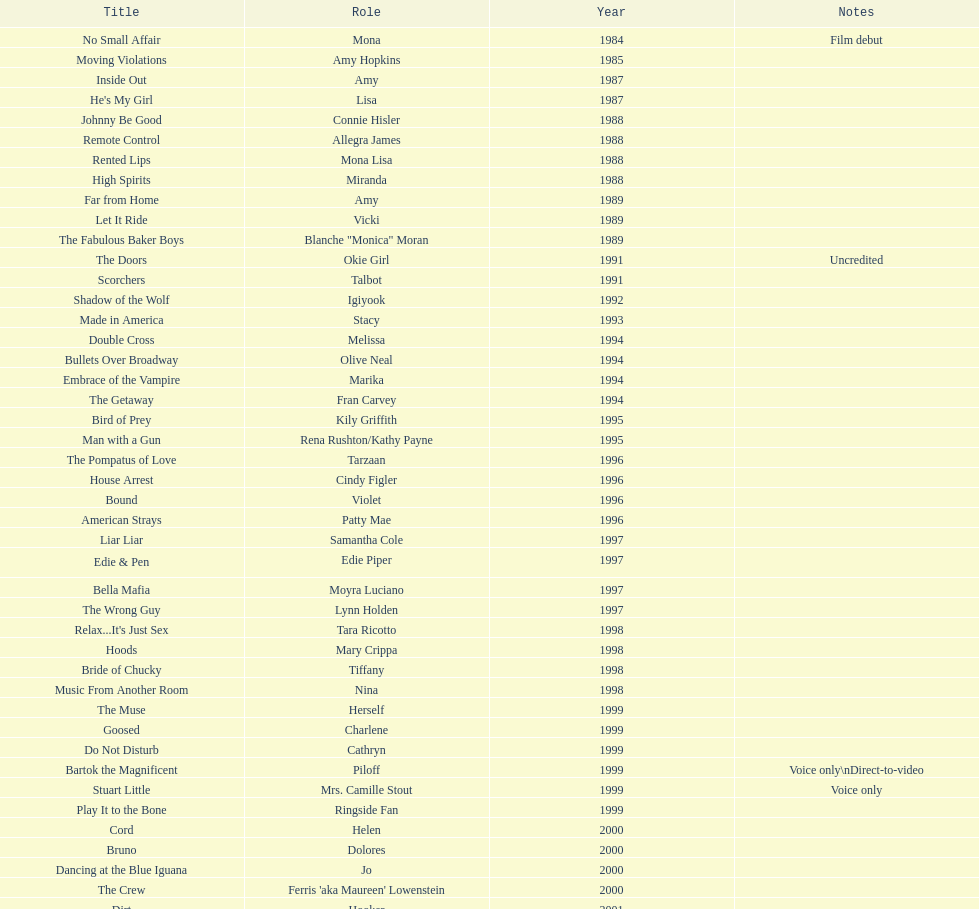Which film aired in 1994 and has marika as the role? Embrace of the Vampire. 